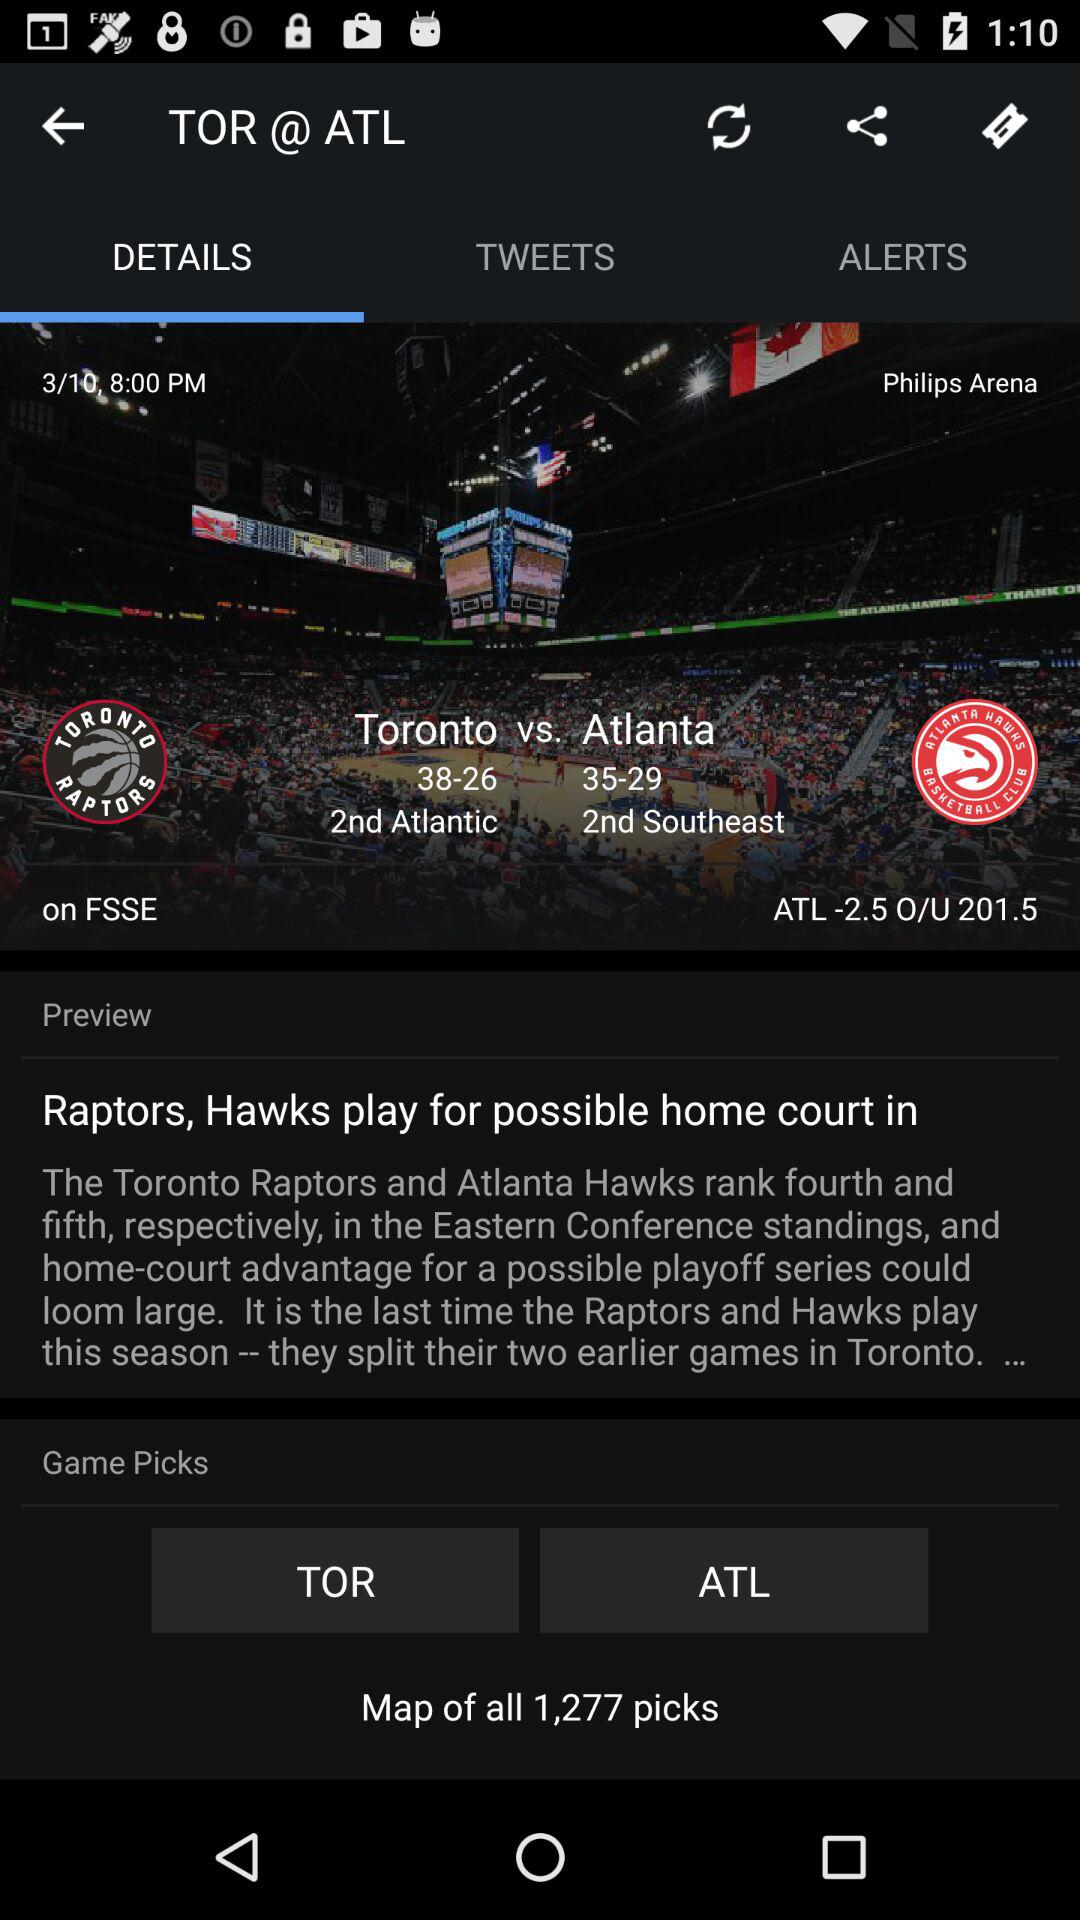What are the figures for Atlanta? The figures are 35–29. 